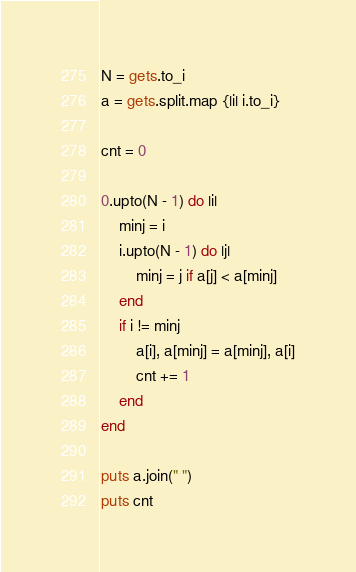Convert code to text. <code><loc_0><loc_0><loc_500><loc_500><_Ruby_>N = gets.to_i
a = gets.split.map {|i| i.to_i}

cnt = 0

0.upto(N - 1) do |i|
	minj = i
	i.upto(N - 1) do |j|
		minj = j if a[j] < a[minj]
	end
	if i != minj
		a[i], a[minj] = a[minj], a[i]
		cnt += 1
	end
end

puts a.join(" ")
puts cnt</code> 